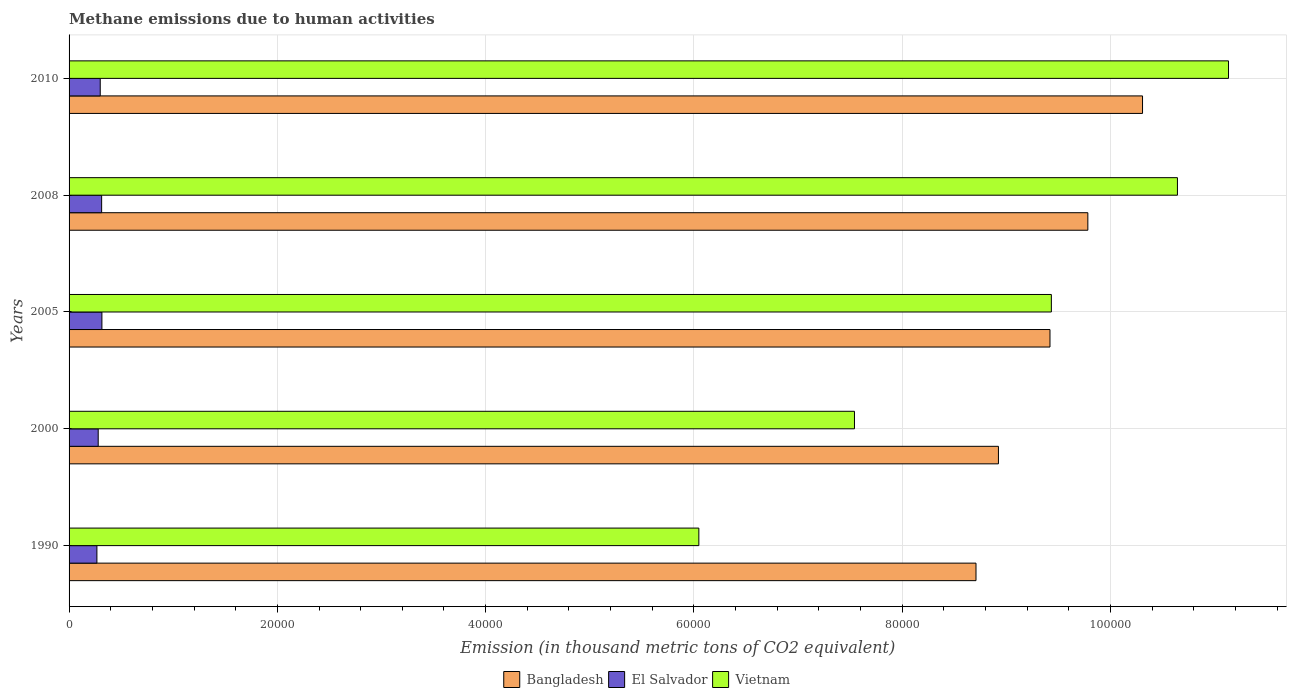How many different coloured bars are there?
Make the answer very short. 3. Are the number of bars on each tick of the Y-axis equal?
Your answer should be very brief. Yes. In how many cases, is the number of bars for a given year not equal to the number of legend labels?
Offer a very short reply. 0. What is the amount of methane emitted in Vietnam in 2000?
Make the answer very short. 7.54e+04. Across all years, what is the maximum amount of methane emitted in Vietnam?
Your response must be concise. 1.11e+05. Across all years, what is the minimum amount of methane emitted in Vietnam?
Offer a terse response. 6.05e+04. In which year was the amount of methane emitted in Bangladesh maximum?
Your answer should be very brief. 2010. In which year was the amount of methane emitted in Bangladesh minimum?
Ensure brevity in your answer.  1990. What is the total amount of methane emitted in Bangladesh in the graph?
Your answer should be very brief. 4.71e+05. What is the difference between the amount of methane emitted in El Salvador in 2008 and that in 2010?
Provide a succinct answer. 135.5. What is the difference between the amount of methane emitted in Bangladesh in 2010 and the amount of methane emitted in El Salvador in 2005?
Keep it short and to the point. 9.99e+04. What is the average amount of methane emitted in Bangladesh per year?
Keep it short and to the point. 9.43e+04. In the year 2000, what is the difference between the amount of methane emitted in Vietnam and amount of methane emitted in Bangladesh?
Your response must be concise. -1.38e+04. In how many years, is the amount of methane emitted in Bangladesh greater than 80000 thousand metric tons?
Your response must be concise. 5. What is the ratio of the amount of methane emitted in Bangladesh in 1990 to that in 2000?
Give a very brief answer. 0.98. What is the difference between the highest and the second highest amount of methane emitted in Vietnam?
Ensure brevity in your answer.  4904.7. What is the difference between the highest and the lowest amount of methane emitted in Bangladesh?
Provide a short and direct response. 1.60e+04. In how many years, is the amount of methane emitted in Bangladesh greater than the average amount of methane emitted in Bangladesh taken over all years?
Provide a succinct answer. 2. Is the sum of the amount of methane emitted in El Salvador in 2000 and 2005 greater than the maximum amount of methane emitted in Bangladesh across all years?
Provide a short and direct response. No. What does the 3rd bar from the top in 2010 represents?
Your answer should be very brief. Bangladesh. What does the 3rd bar from the bottom in 2000 represents?
Offer a terse response. Vietnam. Are all the bars in the graph horizontal?
Give a very brief answer. Yes. What is the difference between two consecutive major ticks on the X-axis?
Provide a succinct answer. 2.00e+04. Are the values on the major ticks of X-axis written in scientific E-notation?
Your response must be concise. No. Does the graph contain any zero values?
Your response must be concise. No. Where does the legend appear in the graph?
Ensure brevity in your answer.  Bottom center. How many legend labels are there?
Your answer should be very brief. 3. What is the title of the graph?
Make the answer very short. Methane emissions due to human activities. What is the label or title of the X-axis?
Make the answer very short. Emission (in thousand metric tons of CO2 equivalent). What is the Emission (in thousand metric tons of CO2 equivalent) of Bangladesh in 1990?
Your response must be concise. 8.71e+04. What is the Emission (in thousand metric tons of CO2 equivalent) in El Salvador in 1990?
Provide a short and direct response. 2672.9. What is the Emission (in thousand metric tons of CO2 equivalent) of Vietnam in 1990?
Provide a succinct answer. 6.05e+04. What is the Emission (in thousand metric tons of CO2 equivalent) of Bangladesh in 2000?
Your answer should be very brief. 8.92e+04. What is the Emission (in thousand metric tons of CO2 equivalent) of El Salvador in 2000?
Provide a short and direct response. 2798.1. What is the Emission (in thousand metric tons of CO2 equivalent) of Vietnam in 2000?
Keep it short and to the point. 7.54e+04. What is the Emission (in thousand metric tons of CO2 equivalent) of Bangladesh in 2005?
Keep it short and to the point. 9.42e+04. What is the Emission (in thousand metric tons of CO2 equivalent) in El Salvador in 2005?
Provide a succinct answer. 3152.8. What is the Emission (in thousand metric tons of CO2 equivalent) of Vietnam in 2005?
Ensure brevity in your answer.  9.43e+04. What is the Emission (in thousand metric tons of CO2 equivalent) in Bangladesh in 2008?
Your answer should be compact. 9.78e+04. What is the Emission (in thousand metric tons of CO2 equivalent) of El Salvador in 2008?
Offer a very short reply. 3127.7. What is the Emission (in thousand metric tons of CO2 equivalent) in Vietnam in 2008?
Make the answer very short. 1.06e+05. What is the Emission (in thousand metric tons of CO2 equivalent) of Bangladesh in 2010?
Provide a short and direct response. 1.03e+05. What is the Emission (in thousand metric tons of CO2 equivalent) of El Salvador in 2010?
Keep it short and to the point. 2992.2. What is the Emission (in thousand metric tons of CO2 equivalent) of Vietnam in 2010?
Your response must be concise. 1.11e+05. Across all years, what is the maximum Emission (in thousand metric tons of CO2 equivalent) in Bangladesh?
Your answer should be compact. 1.03e+05. Across all years, what is the maximum Emission (in thousand metric tons of CO2 equivalent) of El Salvador?
Provide a short and direct response. 3152.8. Across all years, what is the maximum Emission (in thousand metric tons of CO2 equivalent) in Vietnam?
Your answer should be very brief. 1.11e+05. Across all years, what is the minimum Emission (in thousand metric tons of CO2 equivalent) in Bangladesh?
Make the answer very short. 8.71e+04. Across all years, what is the minimum Emission (in thousand metric tons of CO2 equivalent) of El Salvador?
Your answer should be very brief. 2672.9. Across all years, what is the minimum Emission (in thousand metric tons of CO2 equivalent) in Vietnam?
Offer a very short reply. 6.05e+04. What is the total Emission (in thousand metric tons of CO2 equivalent) of Bangladesh in the graph?
Provide a short and direct response. 4.71e+05. What is the total Emission (in thousand metric tons of CO2 equivalent) of El Salvador in the graph?
Ensure brevity in your answer.  1.47e+04. What is the total Emission (in thousand metric tons of CO2 equivalent) in Vietnam in the graph?
Provide a short and direct response. 4.48e+05. What is the difference between the Emission (in thousand metric tons of CO2 equivalent) in Bangladesh in 1990 and that in 2000?
Provide a short and direct response. -2153.8. What is the difference between the Emission (in thousand metric tons of CO2 equivalent) of El Salvador in 1990 and that in 2000?
Your response must be concise. -125.2. What is the difference between the Emission (in thousand metric tons of CO2 equivalent) of Vietnam in 1990 and that in 2000?
Provide a succinct answer. -1.49e+04. What is the difference between the Emission (in thousand metric tons of CO2 equivalent) of Bangladesh in 1990 and that in 2005?
Offer a terse response. -7104.5. What is the difference between the Emission (in thousand metric tons of CO2 equivalent) in El Salvador in 1990 and that in 2005?
Provide a short and direct response. -479.9. What is the difference between the Emission (in thousand metric tons of CO2 equivalent) of Vietnam in 1990 and that in 2005?
Your answer should be compact. -3.39e+04. What is the difference between the Emission (in thousand metric tons of CO2 equivalent) in Bangladesh in 1990 and that in 2008?
Offer a very short reply. -1.07e+04. What is the difference between the Emission (in thousand metric tons of CO2 equivalent) of El Salvador in 1990 and that in 2008?
Give a very brief answer. -454.8. What is the difference between the Emission (in thousand metric tons of CO2 equivalent) in Vietnam in 1990 and that in 2008?
Your response must be concise. -4.60e+04. What is the difference between the Emission (in thousand metric tons of CO2 equivalent) in Bangladesh in 1990 and that in 2010?
Your answer should be compact. -1.60e+04. What is the difference between the Emission (in thousand metric tons of CO2 equivalent) in El Salvador in 1990 and that in 2010?
Your response must be concise. -319.3. What is the difference between the Emission (in thousand metric tons of CO2 equivalent) in Vietnam in 1990 and that in 2010?
Provide a succinct answer. -5.09e+04. What is the difference between the Emission (in thousand metric tons of CO2 equivalent) in Bangladesh in 2000 and that in 2005?
Your answer should be compact. -4950.7. What is the difference between the Emission (in thousand metric tons of CO2 equivalent) of El Salvador in 2000 and that in 2005?
Provide a succinct answer. -354.7. What is the difference between the Emission (in thousand metric tons of CO2 equivalent) in Vietnam in 2000 and that in 2005?
Keep it short and to the point. -1.89e+04. What is the difference between the Emission (in thousand metric tons of CO2 equivalent) of Bangladesh in 2000 and that in 2008?
Ensure brevity in your answer.  -8585. What is the difference between the Emission (in thousand metric tons of CO2 equivalent) in El Salvador in 2000 and that in 2008?
Make the answer very short. -329.6. What is the difference between the Emission (in thousand metric tons of CO2 equivalent) of Vietnam in 2000 and that in 2008?
Your answer should be very brief. -3.10e+04. What is the difference between the Emission (in thousand metric tons of CO2 equivalent) in Bangladesh in 2000 and that in 2010?
Your answer should be compact. -1.38e+04. What is the difference between the Emission (in thousand metric tons of CO2 equivalent) of El Salvador in 2000 and that in 2010?
Offer a terse response. -194.1. What is the difference between the Emission (in thousand metric tons of CO2 equivalent) in Vietnam in 2000 and that in 2010?
Make the answer very short. -3.59e+04. What is the difference between the Emission (in thousand metric tons of CO2 equivalent) in Bangladesh in 2005 and that in 2008?
Your answer should be very brief. -3634.3. What is the difference between the Emission (in thousand metric tons of CO2 equivalent) of El Salvador in 2005 and that in 2008?
Your answer should be compact. 25.1. What is the difference between the Emission (in thousand metric tons of CO2 equivalent) in Vietnam in 2005 and that in 2008?
Make the answer very short. -1.21e+04. What is the difference between the Emission (in thousand metric tons of CO2 equivalent) in Bangladesh in 2005 and that in 2010?
Make the answer very short. -8885.7. What is the difference between the Emission (in thousand metric tons of CO2 equivalent) in El Salvador in 2005 and that in 2010?
Keep it short and to the point. 160.6. What is the difference between the Emission (in thousand metric tons of CO2 equivalent) in Vietnam in 2005 and that in 2010?
Keep it short and to the point. -1.70e+04. What is the difference between the Emission (in thousand metric tons of CO2 equivalent) in Bangladesh in 2008 and that in 2010?
Give a very brief answer. -5251.4. What is the difference between the Emission (in thousand metric tons of CO2 equivalent) in El Salvador in 2008 and that in 2010?
Provide a short and direct response. 135.5. What is the difference between the Emission (in thousand metric tons of CO2 equivalent) of Vietnam in 2008 and that in 2010?
Your answer should be very brief. -4904.7. What is the difference between the Emission (in thousand metric tons of CO2 equivalent) of Bangladesh in 1990 and the Emission (in thousand metric tons of CO2 equivalent) of El Salvador in 2000?
Ensure brevity in your answer.  8.43e+04. What is the difference between the Emission (in thousand metric tons of CO2 equivalent) in Bangladesh in 1990 and the Emission (in thousand metric tons of CO2 equivalent) in Vietnam in 2000?
Your answer should be very brief. 1.17e+04. What is the difference between the Emission (in thousand metric tons of CO2 equivalent) in El Salvador in 1990 and the Emission (in thousand metric tons of CO2 equivalent) in Vietnam in 2000?
Provide a succinct answer. -7.27e+04. What is the difference between the Emission (in thousand metric tons of CO2 equivalent) in Bangladesh in 1990 and the Emission (in thousand metric tons of CO2 equivalent) in El Salvador in 2005?
Keep it short and to the point. 8.39e+04. What is the difference between the Emission (in thousand metric tons of CO2 equivalent) in Bangladesh in 1990 and the Emission (in thousand metric tons of CO2 equivalent) in Vietnam in 2005?
Offer a terse response. -7235.9. What is the difference between the Emission (in thousand metric tons of CO2 equivalent) in El Salvador in 1990 and the Emission (in thousand metric tons of CO2 equivalent) in Vietnam in 2005?
Your response must be concise. -9.17e+04. What is the difference between the Emission (in thousand metric tons of CO2 equivalent) of Bangladesh in 1990 and the Emission (in thousand metric tons of CO2 equivalent) of El Salvador in 2008?
Your response must be concise. 8.40e+04. What is the difference between the Emission (in thousand metric tons of CO2 equivalent) of Bangladesh in 1990 and the Emission (in thousand metric tons of CO2 equivalent) of Vietnam in 2008?
Keep it short and to the point. -1.93e+04. What is the difference between the Emission (in thousand metric tons of CO2 equivalent) of El Salvador in 1990 and the Emission (in thousand metric tons of CO2 equivalent) of Vietnam in 2008?
Your response must be concise. -1.04e+05. What is the difference between the Emission (in thousand metric tons of CO2 equivalent) in Bangladesh in 1990 and the Emission (in thousand metric tons of CO2 equivalent) in El Salvador in 2010?
Your answer should be very brief. 8.41e+04. What is the difference between the Emission (in thousand metric tons of CO2 equivalent) of Bangladesh in 1990 and the Emission (in thousand metric tons of CO2 equivalent) of Vietnam in 2010?
Your answer should be very brief. -2.42e+04. What is the difference between the Emission (in thousand metric tons of CO2 equivalent) in El Salvador in 1990 and the Emission (in thousand metric tons of CO2 equivalent) in Vietnam in 2010?
Ensure brevity in your answer.  -1.09e+05. What is the difference between the Emission (in thousand metric tons of CO2 equivalent) of Bangladesh in 2000 and the Emission (in thousand metric tons of CO2 equivalent) of El Salvador in 2005?
Offer a terse response. 8.61e+04. What is the difference between the Emission (in thousand metric tons of CO2 equivalent) in Bangladesh in 2000 and the Emission (in thousand metric tons of CO2 equivalent) in Vietnam in 2005?
Offer a terse response. -5082.1. What is the difference between the Emission (in thousand metric tons of CO2 equivalent) in El Salvador in 2000 and the Emission (in thousand metric tons of CO2 equivalent) in Vietnam in 2005?
Give a very brief answer. -9.15e+04. What is the difference between the Emission (in thousand metric tons of CO2 equivalent) of Bangladesh in 2000 and the Emission (in thousand metric tons of CO2 equivalent) of El Salvador in 2008?
Keep it short and to the point. 8.61e+04. What is the difference between the Emission (in thousand metric tons of CO2 equivalent) of Bangladesh in 2000 and the Emission (in thousand metric tons of CO2 equivalent) of Vietnam in 2008?
Offer a terse response. -1.72e+04. What is the difference between the Emission (in thousand metric tons of CO2 equivalent) of El Salvador in 2000 and the Emission (in thousand metric tons of CO2 equivalent) of Vietnam in 2008?
Give a very brief answer. -1.04e+05. What is the difference between the Emission (in thousand metric tons of CO2 equivalent) of Bangladesh in 2000 and the Emission (in thousand metric tons of CO2 equivalent) of El Salvador in 2010?
Ensure brevity in your answer.  8.63e+04. What is the difference between the Emission (in thousand metric tons of CO2 equivalent) in Bangladesh in 2000 and the Emission (in thousand metric tons of CO2 equivalent) in Vietnam in 2010?
Ensure brevity in your answer.  -2.21e+04. What is the difference between the Emission (in thousand metric tons of CO2 equivalent) in El Salvador in 2000 and the Emission (in thousand metric tons of CO2 equivalent) in Vietnam in 2010?
Offer a terse response. -1.09e+05. What is the difference between the Emission (in thousand metric tons of CO2 equivalent) in Bangladesh in 2005 and the Emission (in thousand metric tons of CO2 equivalent) in El Salvador in 2008?
Offer a very short reply. 9.11e+04. What is the difference between the Emission (in thousand metric tons of CO2 equivalent) of Bangladesh in 2005 and the Emission (in thousand metric tons of CO2 equivalent) of Vietnam in 2008?
Your answer should be compact. -1.22e+04. What is the difference between the Emission (in thousand metric tons of CO2 equivalent) in El Salvador in 2005 and the Emission (in thousand metric tons of CO2 equivalent) in Vietnam in 2008?
Provide a short and direct response. -1.03e+05. What is the difference between the Emission (in thousand metric tons of CO2 equivalent) in Bangladesh in 2005 and the Emission (in thousand metric tons of CO2 equivalent) in El Salvador in 2010?
Offer a terse response. 9.12e+04. What is the difference between the Emission (in thousand metric tons of CO2 equivalent) in Bangladesh in 2005 and the Emission (in thousand metric tons of CO2 equivalent) in Vietnam in 2010?
Provide a short and direct response. -1.71e+04. What is the difference between the Emission (in thousand metric tons of CO2 equivalent) in El Salvador in 2005 and the Emission (in thousand metric tons of CO2 equivalent) in Vietnam in 2010?
Offer a very short reply. -1.08e+05. What is the difference between the Emission (in thousand metric tons of CO2 equivalent) of Bangladesh in 2008 and the Emission (in thousand metric tons of CO2 equivalent) of El Salvador in 2010?
Provide a short and direct response. 9.48e+04. What is the difference between the Emission (in thousand metric tons of CO2 equivalent) of Bangladesh in 2008 and the Emission (in thousand metric tons of CO2 equivalent) of Vietnam in 2010?
Keep it short and to the point. -1.35e+04. What is the difference between the Emission (in thousand metric tons of CO2 equivalent) in El Salvador in 2008 and the Emission (in thousand metric tons of CO2 equivalent) in Vietnam in 2010?
Ensure brevity in your answer.  -1.08e+05. What is the average Emission (in thousand metric tons of CO2 equivalent) of Bangladesh per year?
Provide a short and direct response. 9.43e+04. What is the average Emission (in thousand metric tons of CO2 equivalent) in El Salvador per year?
Offer a very short reply. 2948.74. What is the average Emission (in thousand metric tons of CO2 equivalent) of Vietnam per year?
Keep it short and to the point. 8.96e+04. In the year 1990, what is the difference between the Emission (in thousand metric tons of CO2 equivalent) of Bangladesh and Emission (in thousand metric tons of CO2 equivalent) of El Salvador?
Make the answer very short. 8.44e+04. In the year 1990, what is the difference between the Emission (in thousand metric tons of CO2 equivalent) in Bangladesh and Emission (in thousand metric tons of CO2 equivalent) in Vietnam?
Offer a very short reply. 2.66e+04. In the year 1990, what is the difference between the Emission (in thousand metric tons of CO2 equivalent) of El Salvador and Emission (in thousand metric tons of CO2 equivalent) of Vietnam?
Offer a terse response. -5.78e+04. In the year 2000, what is the difference between the Emission (in thousand metric tons of CO2 equivalent) in Bangladesh and Emission (in thousand metric tons of CO2 equivalent) in El Salvador?
Your answer should be compact. 8.64e+04. In the year 2000, what is the difference between the Emission (in thousand metric tons of CO2 equivalent) of Bangladesh and Emission (in thousand metric tons of CO2 equivalent) of Vietnam?
Keep it short and to the point. 1.38e+04. In the year 2000, what is the difference between the Emission (in thousand metric tons of CO2 equivalent) in El Salvador and Emission (in thousand metric tons of CO2 equivalent) in Vietnam?
Offer a very short reply. -7.26e+04. In the year 2005, what is the difference between the Emission (in thousand metric tons of CO2 equivalent) of Bangladesh and Emission (in thousand metric tons of CO2 equivalent) of El Salvador?
Give a very brief answer. 9.10e+04. In the year 2005, what is the difference between the Emission (in thousand metric tons of CO2 equivalent) of Bangladesh and Emission (in thousand metric tons of CO2 equivalent) of Vietnam?
Ensure brevity in your answer.  -131.4. In the year 2005, what is the difference between the Emission (in thousand metric tons of CO2 equivalent) in El Salvador and Emission (in thousand metric tons of CO2 equivalent) in Vietnam?
Keep it short and to the point. -9.12e+04. In the year 2008, what is the difference between the Emission (in thousand metric tons of CO2 equivalent) in Bangladesh and Emission (in thousand metric tons of CO2 equivalent) in El Salvador?
Your answer should be compact. 9.47e+04. In the year 2008, what is the difference between the Emission (in thousand metric tons of CO2 equivalent) in Bangladesh and Emission (in thousand metric tons of CO2 equivalent) in Vietnam?
Your answer should be very brief. -8604.5. In the year 2008, what is the difference between the Emission (in thousand metric tons of CO2 equivalent) in El Salvador and Emission (in thousand metric tons of CO2 equivalent) in Vietnam?
Your answer should be very brief. -1.03e+05. In the year 2010, what is the difference between the Emission (in thousand metric tons of CO2 equivalent) of Bangladesh and Emission (in thousand metric tons of CO2 equivalent) of El Salvador?
Offer a terse response. 1.00e+05. In the year 2010, what is the difference between the Emission (in thousand metric tons of CO2 equivalent) in Bangladesh and Emission (in thousand metric tons of CO2 equivalent) in Vietnam?
Make the answer very short. -8257.8. In the year 2010, what is the difference between the Emission (in thousand metric tons of CO2 equivalent) in El Salvador and Emission (in thousand metric tons of CO2 equivalent) in Vietnam?
Offer a terse response. -1.08e+05. What is the ratio of the Emission (in thousand metric tons of CO2 equivalent) of Bangladesh in 1990 to that in 2000?
Provide a succinct answer. 0.98. What is the ratio of the Emission (in thousand metric tons of CO2 equivalent) of El Salvador in 1990 to that in 2000?
Offer a terse response. 0.96. What is the ratio of the Emission (in thousand metric tons of CO2 equivalent) of Vietnam in 1990 to that in 2000?
Your answer should be very brief. 0.8. What is the ratio of the Emission (in thousand metric tons of CO2 equivalent) in Bangladesh in 1990 to that in 2005?
Keep it short and to the point. 0.92. What is the ratio of the Emission (in thousand metric tons of CO2 equivalent) of El Salvador in 1990 to that in 2005?
Ensure brevity in your answer.  0.85. What is the ratio of the Emission (in thousand metric tons of CO2 equivalent) in Vietnam in 1990 to that in 2005?
Provide a short and direct response. 0.64. What is the ratio of the Emission (in thousand metric tons of CO2 equivalent) of Bangladesh in 1990 to that in 2008?
Give a very brief answer. 0.89. What is the ratio of the Emission (in thousand metric tons of CO2 equivalent) in El Salvador in 1990 to that in 2008?
Provide a short and direct response. 0.85. What is the ratio of the Emission (in thousand metric tons of CO2 equivalent) of Vietnam in 1990 to that in 2008?
Your response must be concise. 0.57. What is the ratio of the Emission (in thousand metric tons of CO2 equivalent) of Bangladesh in 1990 to that in 2010?
Make the answer very short. 0.84. What is the ratio of the Emission (in thousand metric tons of CO2 equivalent) in El Salvador in 1990 to that in 2010?
Provide a succinct answer. 0.89. What is the ratio of the Emission (in thousand metric tons of CO2 equivalent) in Vietnam in 1990 to that in 2010?
Provide a short and direct response. 0.54. What is the ratio of the Emission (in thousand metric tons of CO2 equivalent) in Bangladesh in 2000 to that in 2005?
Make the answer very short. 0.95. What is the ratio of the Emission (in thousand metric tons of CO2 equivalent) in El Salvador in 2000 to that in 2005?
Provide a short and direct response. 0.89. What is the ratio of the Emission (in thousand metric tons of CO2 equivalent) of Vietnam in 2000 to that in 2005?
Keep it short and to the point. 0.8. What is the ratio of the Emission (in thousand metric tons of CO2 equivalent) in Bangladesh in 2000 to that in 2008?
Ensure brevity in your answer.  0.91. What is the ratio of the Emission (in thousand metric tons of CO2 equivalent) of El Salvador in 2000 to that in 2008?
Make the answer very short. 0.89. What is the ratio of the Emission (in thousand metric tons of CO2 equivalent) in Vietnam in 2000 to that in 2008?
Your answer should be very brief. 0.71. What is the ratio of the Emission (in thousand metric tons of CO2 equivalent) in Bangladesh in 2000 to that in 2010?
Keep it short and to the point. 0.87. What is the ratio of the Emission (in thousand metric tons of CO2 equivalent) of El Salvador in 2000 to that in 2010?
Your answer should be very brief. 0.94. What is the ratio of the Emission (in thousand metric tons of CO2 equivalent) of Vietnam in 2000 to that in 2010?
Make the answer very short. 0.68. What is the ratio of the Emission (in thousand metric tons of CO2 equivalent) of Bangladesh in 2005 to that in 2008?
Your answer should be compact. 0.96. What is the ratio of the Emission (in thousand metric tons of CO2 equivalent) in Vietnam in 2005 to that in 2008?
Provide a short and direct response. 0.89. What is the ratio of the Emission (in thousand metric tons of CO2 equivalent) of Bangladesh in 2005 to that in 2010?
Keep it short and to the point. 0.91. What is the ratio of the Emission (in thousand metric tons of CO2 equivalent) of El Salvador in 2005 to that in 2010?
Your answer should be compact. 1.05. What is the ratio of the Emission (in thousand metric tons of CO2 equivalent) in Vietnam in 2005 to that in 2010?
Your response must be concise. 0.85. What is the ratio of the Emission (in thousand metric tons of CO2 equivalent) of Bangladesh in 2008 to that in 2010?
Offer a very short reply. 0.95. What is the ratio of the Emission (in thousand metric tons of CO2 equivalent) in El Salvador in 2008 to that in 2010?
Give a very brief answer. 1.05. What is the ratio of the Emission (in thousand metric tons of CO2 equivalent) of Vietnam in 2008 to that in 2010?
Your response must be concise. 0.96. What is the difference between the highest and the second highest Emission (in thousand metric tons of CO2 equivalent) of Bangladesh?
Give a very brief answer. 5251.4. What is the difference between the highest and the second highest Emission (in thousand metric tons of CO2 equivalent) of El Salvador?
Give a very brief answer. 25.1. What is the difference between the highest and the second highest Emission (in thousand metric tons of CO2 equivalent) in Vietnam?
Give a very brief answer. 4904.7. What is the difference between the highest and the lowest Emission (in thousand metric tons of CO2 equivalent) of Bangladesh?
Make the answer very short. 1.60e+04. What is the difference between the highest and the lowest Emission (in thousand metric tons of CO2 equivalent) in El Salvador?
Your response must be concise. 479.9. What is the difference between the highest and the lowest Emission (in thousand metric tons of CO2 equivalent) of Vietnam?
Keep it short and to the point. 5.09e+04. 